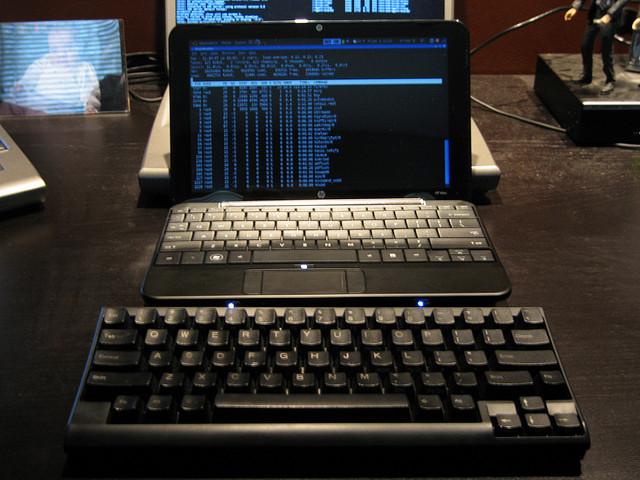What is the brand name on the keyboard?
Answer briefly. Dell. Is this desk dusty?
Concise answer only. Yes. What color is the laptop?
Concise answer only. Black. How many keyboards are on the desk?
Write a very short answer. 2. What picture is in the far left screen?
Be succinct. Baby. Is there a mouse?
Write a very short answer. No. 